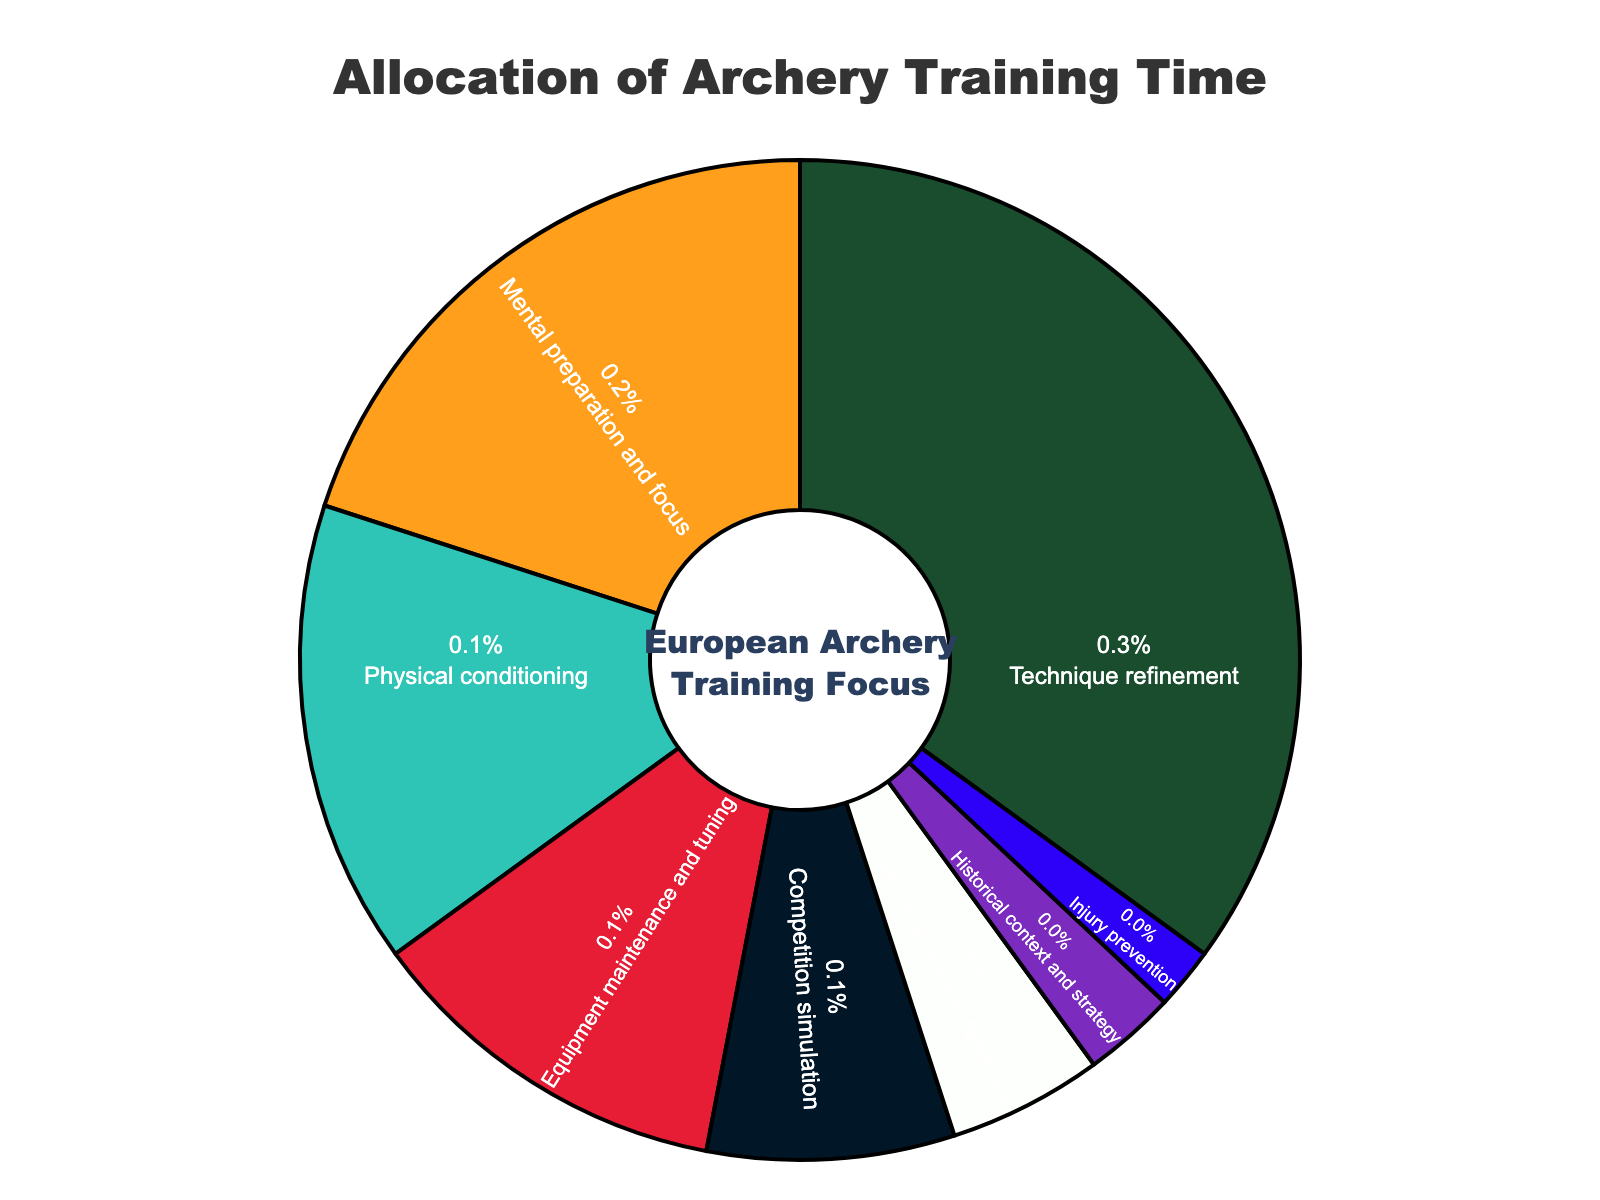what percentage of training time is allocated to mental preparation and focus? Mental preparation and focus is a specific segment in the pie chart. According to the figure, it is labeled with a percentage value of 20%.
Answer: 20% which aspect has the smallest allocation of training time? The segment labeled "Injury prevention" has the smallest allocation. According to the data, it is 2%.
Answer: Injury prevention what is the combined percentage of training time allocated to video analysis and competition simulation? The percentages for video analysis and competition simulation are 5% and 8%, respectively. Adding them together gives 5% + 8% = 13%.
Answer: 13% how does the percentage allocated to physical conditioning compare to that of equipment maintenance? The percentage for physical conditioning is 15%, while that for equipment maintenance and tuning is 12%. Physical conditioning has a higher allocation by 3%.
Answer: Physical conditioning has 3% more what is the total percentage of training time spent on activities related to mental and physical aspects (mental preparation, physical conditioning, historical context, and injury prevention)? Summing up the percentages for mental preparation (20%), physical conditioning (15%), historical context (3%), and injury prevention (2%) gives 20% + 15% + 3% + 2% = 40%.
Answer: 40% which aspect has a larger allocation of training time: technique refinement or competition simulation? Technique refinement is allocated 35%, while competition simulation is allocated 8%. Therefore, technique refinement has a larger allocation.
Answer: Technique refinement how much more time is allocated to equipment maintenance compared to injury prevention? Equipment maintenance is allocated 12%, while injury prevention is allocated 2%. The difference is 12% - 2% = 10%.
Answer: 10% if video analysis and feedback increased by 3 percentage points, what would be the new total allocation for video analysis? Originally, video analysis is allocated 5%. With an increase of 3 percentage points, the new allocation would be 5% + 3% = 8%.
Answer: 8% which activity categories are marked in green and red, and what are their respective percentages? The green segment is labeled "Technique refinement" with 35%, and the red segment is labeled "Equipment maintenance and tuning" with 12%.
Answer: Technique refinement (35%) and Equipment maintenance (12%) if the time allocated to historical context and strategy was doubled, how would the new percentage compare to mental preparation and focus? Doubling the original 3% allocation for historical context and strategy gives 3% * 2 = 6%. This is still less than the 20% allocated to mental preparation and focus.
Answer: It would still be less 